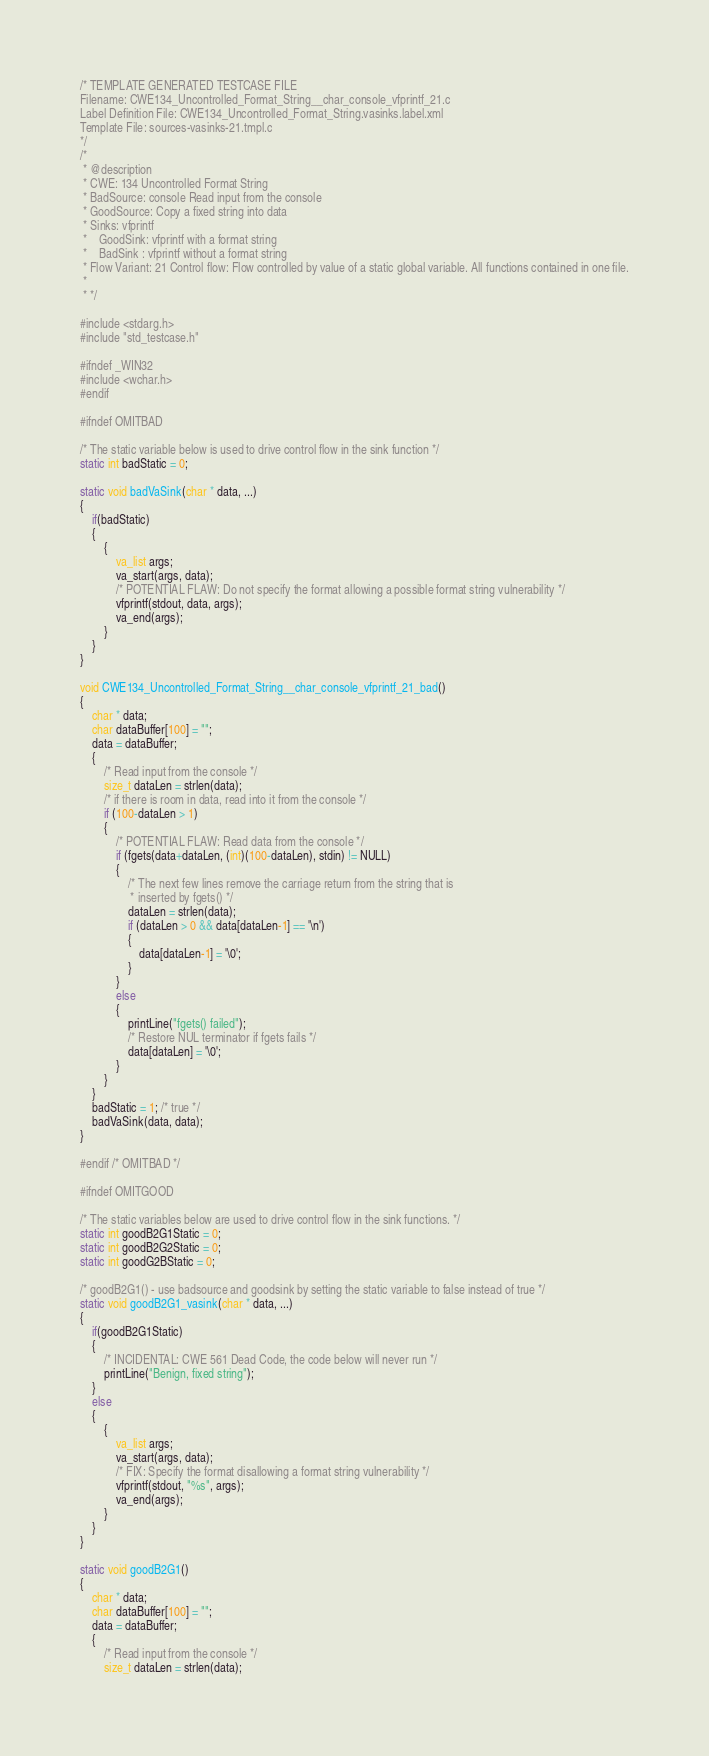<code> <loc_0><loc_0><loc_500><loc_500><_C_>/* TEMPLATE GENERATED TESTCASE FILE
Filename: CWE134_Uncontrolled_Format_String__char_console_vfprintf_21.c
Label Definition File: CWE134_Uncontrolled_Format_String.vasinks.label.xml
Template File: sources-vasinks-21.tmpl.c
*/
/*
 * @description
 * CWE: 134 Uncontrolled Format String
 * BadSource: console Read input from the console
 * GoodSource: Copy a fixed string into data
 * Sinks: vfprintf
 *    GoodSink: vfprintf with a format string
 *    BadSink : vfprintf without a format string
 * Flow Variant: 21 Control flow: Flow controlled by value of a static global variable. All functions contained in one file.
 *
 * */

#include <stdarg.h>
#include "std_testcase.h"

#ifndef _WIN32
#include <wchar.h>
#endif

#ifndef OMITBAD

/* The static variable below is used to drive control flow in the sink function */
static int badStatic = 0;

static void badVaSink(char * data, ...)
{
    if(badStatic)
    {
        {
            va_list args;
            va_start(args, data);
            /* POTENTIAL FLAW: Do not specify the format allowing a possible format string vulnerability */
            vfprintf(stdout, data, args);
            va_end(args);
        }
    }
}

void CWE134_Uncontrolled_Format_String__char_console_vfprintf_21_bad()
{
    char * data;
    char dataBuffer[100] = "";
    data = dataBuffer;
    {
        /* Read input from the console */
        size_t dataLen = strlen(data);
        /* if there is room in data, read into it from the console */
        if (100-dataLen > 1)
        {
            /* POTENTIAL FLAW: Read data from the console */
            if (fgets(data+dataLen, (int)(100-dataLen), stdin) != NULL)
            {
                /* The next few lines remove the carriage return from the string that is
                 * inserted by fgets() */
                dataLen = strlen(data);
                if (dataLen > 0 && data[dataLen-1] == '\n')
                {
                    data[dataLen-1] = '\0';
                }
            }
            else
            {
                printLine("fgets() failed");
                /* Restore NUL terminator if fgets fails */
                data[dataLen] = '\0';
            }
        }
    }
    badStatic = 1; /* true */
    badVaSink(data, data);
}

#endif /* OMITBAD */

#ifndef OMITGOOD

/* The static variables below are used to drive control flow in the sink functions. */
static int goodB2G1Static = 0;
static int goodB2G2Static = 0;
static int goodG2BStatic = 0;

/* goodB2G1() - use badsource and goodsink by setting the static variable to false instead of true */
static void goodB2G1_vasink(char * data, ...)
{
    if(goodB2G1Static)
    {
        /* INCIDENTAL: CWE 561 Dead Code, the code below will never run */
        printLine("Benign, fixed string");
    }
    else
    {
        {
            va_list args;
            va_start(args, data);
            /* FIX: Specify the format disallowing a format string vulnerability */
            vfprintf(stdout, "%s", args);
            va_end(args);
        }
    }
}

static void goodB2G1()
{
    char * data;
    char dataBuffer[100] = "";
    data = dataBuffer;
    {
        /* Read input from the console */
        size_t dataLen = strlen(data);</code> 